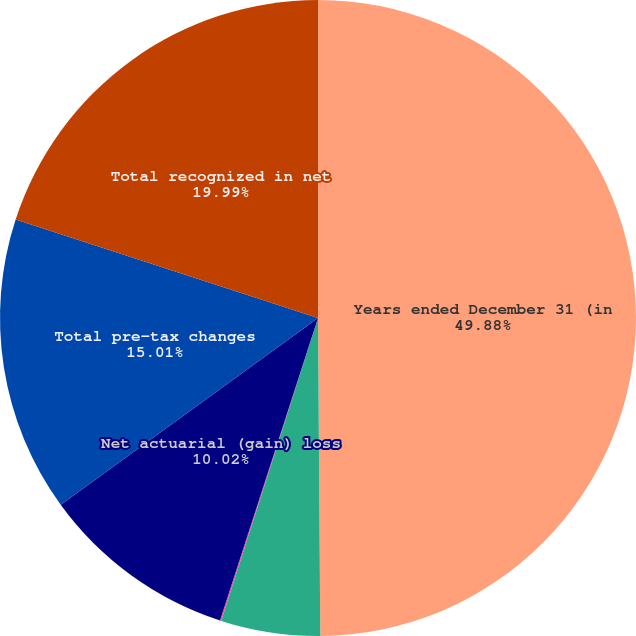Convert chart to OTSL. <chart><loc_0><loc_0><loc_500><loc_500><pie_chart><fcel>Years ended December 31 (in<fcel>Interest cost<fcel>Net periodic benefit (income)<fcel>Net actuarial (gain) loss<fcel>Total pre-tax changes<fcel>Total recognized in net<nl><fcel>49.89%<fcel>5.04%<fcel>0.06%<fcel>10.02%<fcel>15.01%<fcel>19.99%<nl></chart> 